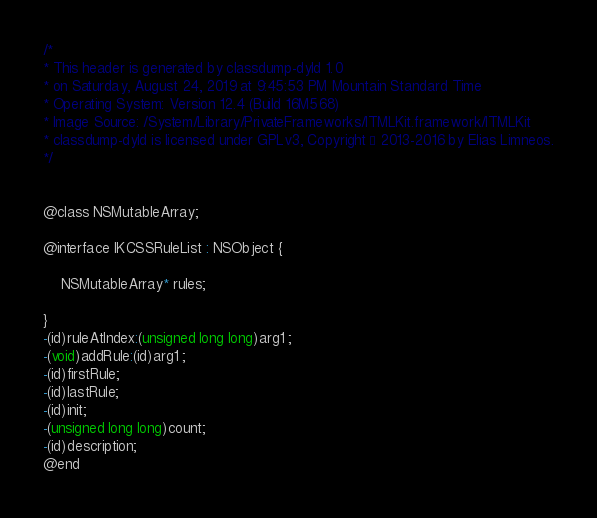Convert code to text. <code><loc_0><loc_0><loc_500><loc_500><_C_>/*
* This header is generated by classdump-dyld 1.0
* on Saturday, August 24, 2019 at 9:45:53 PM Mountain Standard Time
* Operating System: Version 12.4 (Build 16M568)
* Image Source: /System/Library/PrivateFrameworks/ITMLKit.framework/ITMLKit
* classdump-dyld is licensed under GPLv3, Copyright © 2013-2016 by Elias Limneos.
*/


@class NSMutableArray;

@interface IKCSSRuleList : NSObject {

	NSMutableArray* rules;

}
-(id)ruleAtIndex:(unsigned long long)arg1 ;
-(void)addRule:(id)arg1 ;
-(id)firstRule;
-(id)lastRule;
-(id)init;
-(unsigned long long)count;
-(id)description;
@end

</code> 